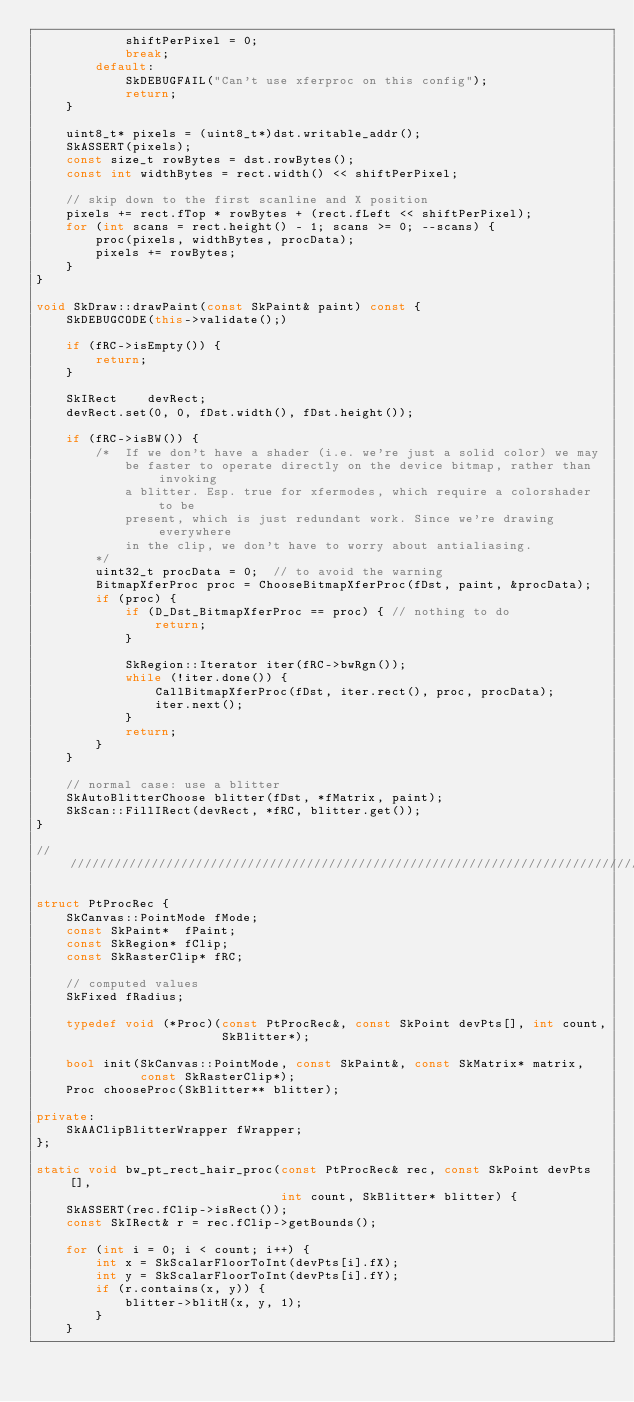Convert code to text. <code><loc_0><loc_0><loc_500><loc_500><_C++_>            shiftPerPixel = 0;
            break;
        default:
            SkDEBUGFAIL("Can't use xferproc on this config");
            return;
    }

    uint8_t* pixels = (uint8_t*)dst.writable_addr();
    SkASSERT(pixels);
    const size_t rowBytes = dst.rowBytes();
    const int widthBytes = rect.width() << shiftPerPixel;

    // skip down to the first scanline and X position
    pixels += rect.fTop * rowBytes + (rect.fLeft << shiftPerPixel);
    for (int scans = rect.height() - 1; scans >= 0; --scans) {
        proc(pixels, widthBytes, procData);
        pixels += rowBytes;
    }
}

void SkDraw::drawPaint(const SkPaint& paint) const {
    SkDEBUGCODE(this->validate();)

    if (fRC->isEmpty()) {
        return;
    }

    SkIRect    devRect;
    devRect.set(0, 0, fDst.width(), fDst.height());

    if (fRC->isBW()) {
        /*  If we don't have a shader (i.e. we're just a solid color) we may
            be faster to operate directly on the device bitmap, rather than invoking
            a blitter. Esp. true for xfermodes, which require a colorshader to be
            present, which is just redundant work. Since we're drawing everywhere
            in the clip, we don't have to worry about antialiasing.
        */
        uint32_t procData = 0;  // to avoid the warning
        BitmapXferProc proc = ChooseBitmapXferProc(fDst, paint, &procData);
        if (proc) {
            if (D_Dst_BitmapXferProc == proc) { // nothing to do
                return;
            }

            SkRegion::Iterator iter(fRC->bwRgn());
            while (!iter.done()) {
                CallBitmapXferProc(fDst, iter.rect(), proc, procData);
                iter.next();
            }
            return;
        }
    }

    // normal case: use a blitter
    SkAutoBlitterChoose blitter(fDst, *fMatrix, paint);
    SkScan::FillIRect(devRect, *fRC, blitter.get());
}

///////////////////////////////////////////////////////////////////////////////

struct PtProcRec {
    SkCanvas::PointMode fMode;
    const SkPaint*  fPaint;
    const SkRegion* fClip;
    const SkRasterClip* fRC;

    // computed values
    SkFixed fRadius;

    typedef void (*Proc)(const PtProcRec&, const SkPoint devPts[], int count,
                         SkBlitter*);

    bool init(SkCanvas::PointMode, const SkPaint&, const SkMatrix* matrix,
              const SkRasterClip*);
    Proc chooseProc(SkBlitter** blitter);

private:
    SkAAClipBlitterWrapper fWrapper;
};

static void bw_pt_rect_hair_proc(const PtProcRec& rec, const SkPoint devPts[],
                                 int count, SkBlitter* blitter) {
    SkASSERT(rec.fClip->isRect());
    const SkIRect& r = rec.fClip->getBounds();

    for (int i = 0; i < count; i++) {
        int x = SkScalarFloorToInt(devPts[i].fX);
        int y = SkScalarFloorToInt(devPts[i].fY);
        if (r.contains(x, y)) {
            blitter->blitH(x, y, 1);
        }
    }</code> 